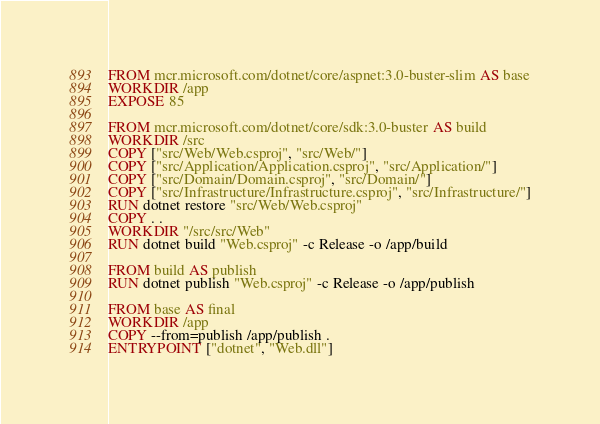<code> <loc_0><loc_0><loc_500><loc_500><_Dockerfile_>FROM mcr.microsoft.com/dotnet/core/aspnet:3.0-buster-slim AS base
WORKDIR /app
EXPOSE 85

FROM mcr.microsoft.com/dotnet/core/sdk:3.0-buster AS build
WORKDIR /src
COPY ["src/Web/Web.csproj", "src/Web/"]
COPY ["src/Application/Application.csproj", "src/Application/"]
COPY ["src/Domain/Domain.csproj", "src/Domain/"]
COPY ["src/Infrastructure/Infrastructure.csproj", "src/Infrastructure/"]
RUN dotnet restore "src/Web/Web.csproj"
COPY . .
WORKDIR "/src/src/Web"
RUN dotnet build "Web.csproj" -c Release -o /app/build

FROM build AS publish
RUN dotnet publish "Web.csproj" -c Release -o /app/publish

FROM base AS final
WORKDIR /app
COPY --from=publish /app/publish .
ENTRYPOINT ["dotnet", "Web.dll"]
</code> 